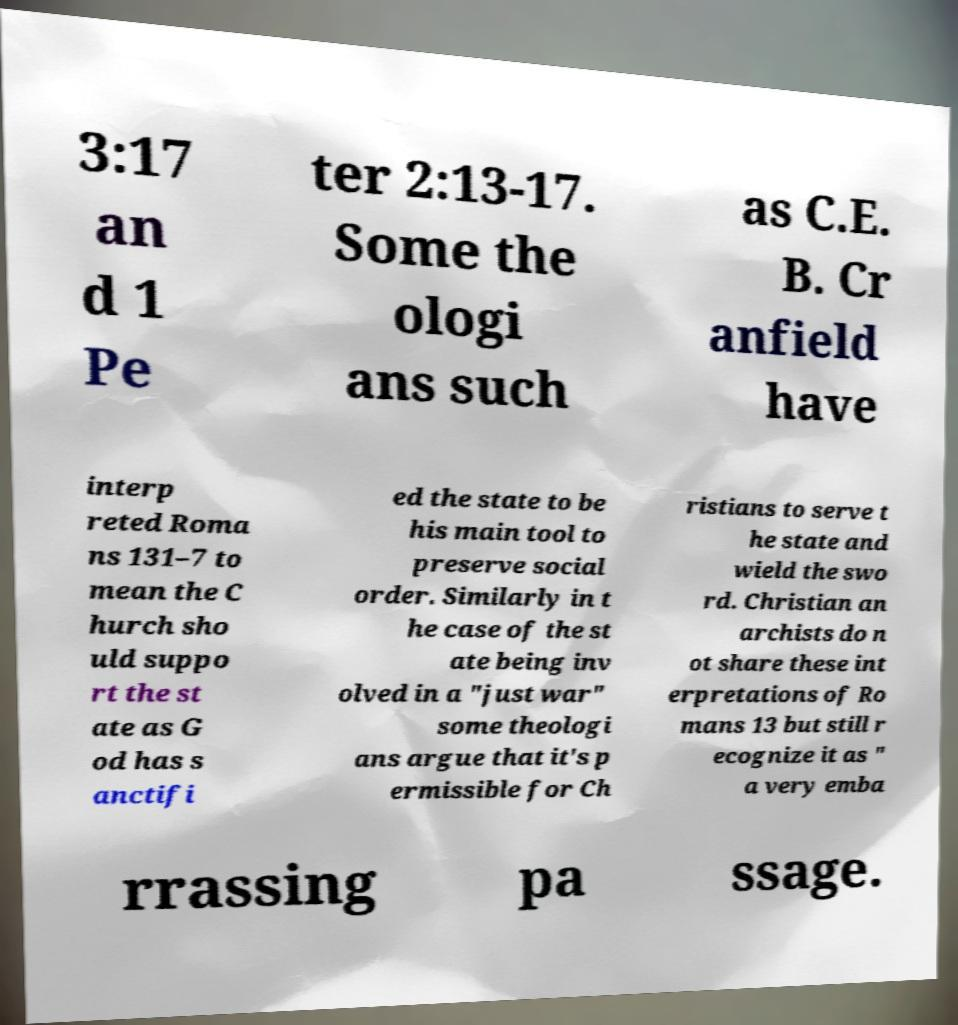Can you read and provide the text displayed in the image?This photo seems to have some interesting text. Can you extract and type it out for me? 3:17 an d 1 Pe ter 2:13-17. Some the ologi ans such as C.E. B. Cr anfield have interp reted Roma ns 131–7 to mean the C hurch sho uld suppo rt the st ate as G od has s anctifi ed the state to be his main tool to preserve social order. Similarly in t he case of the st ate being inv olved in a "just war" some theologi ans argue that it's p ermissible for Ch ristians to serve t he state and wield the swo rd. Christian an archists do n ot share these int erpretations of Ro mans 13 but still r ecognize it as " a very emba rrassing pa ssage. 